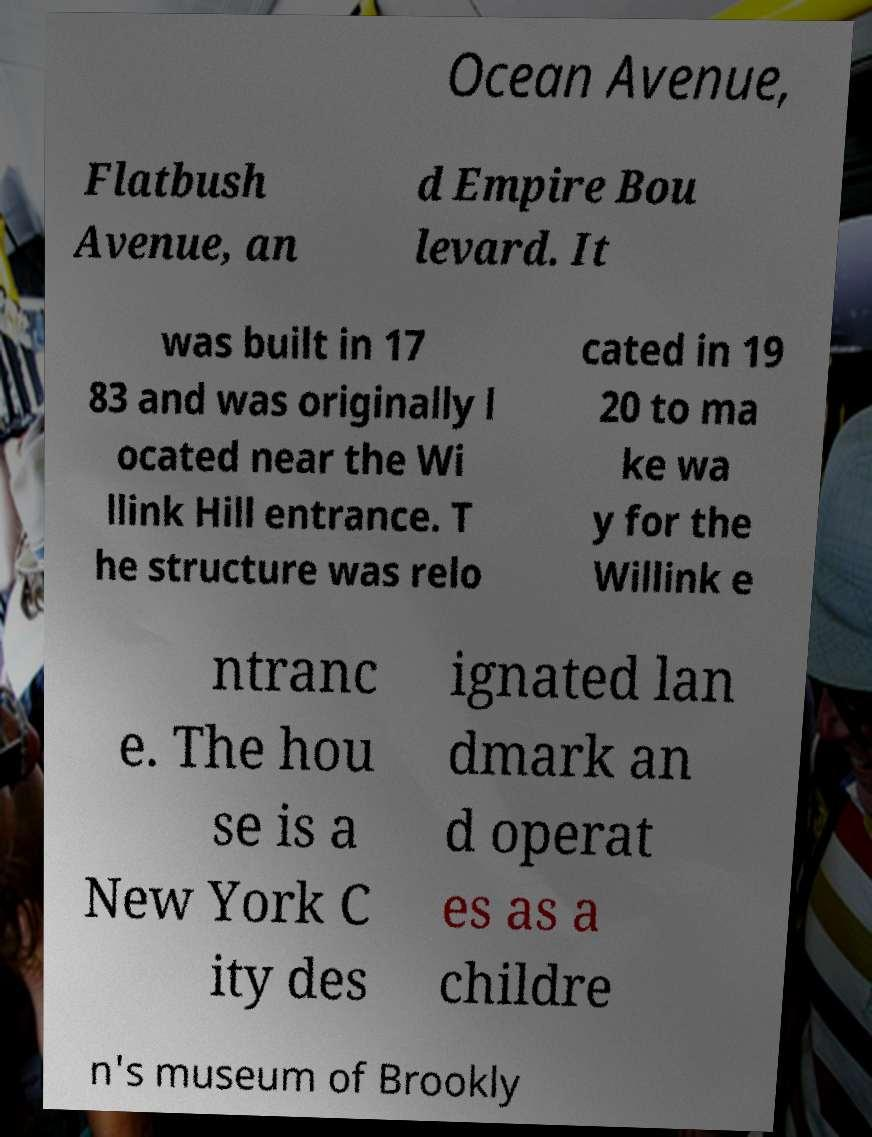I need the written content from this picture converted into text. Can you do that? Ocean Avenue, Flatbush Avenue, an d Empire Bou levard. It was built in 17 83 and was originally l ocated near the Wi llink Hill entrance. T he structure was relo cated in 19 20 to ma ke wa y for the Willink e ntranc e. The hou se is a New York C ity des ignated lan dmark an d operat es as a childre n's museum of Brookly 